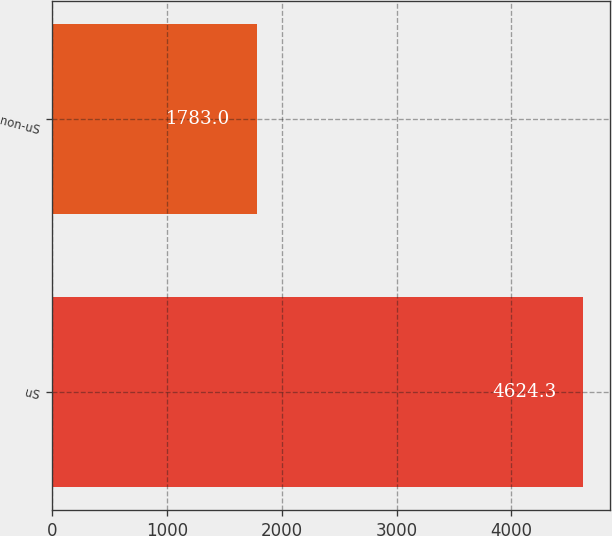Convert chart to OTSL. <chart><loc_0><loc_0><loc_500><loc_500><bar_chart><fcel>uS<fcel>non-uS<nl><fcel>4624.3<fcel>1783<nl></chart> 